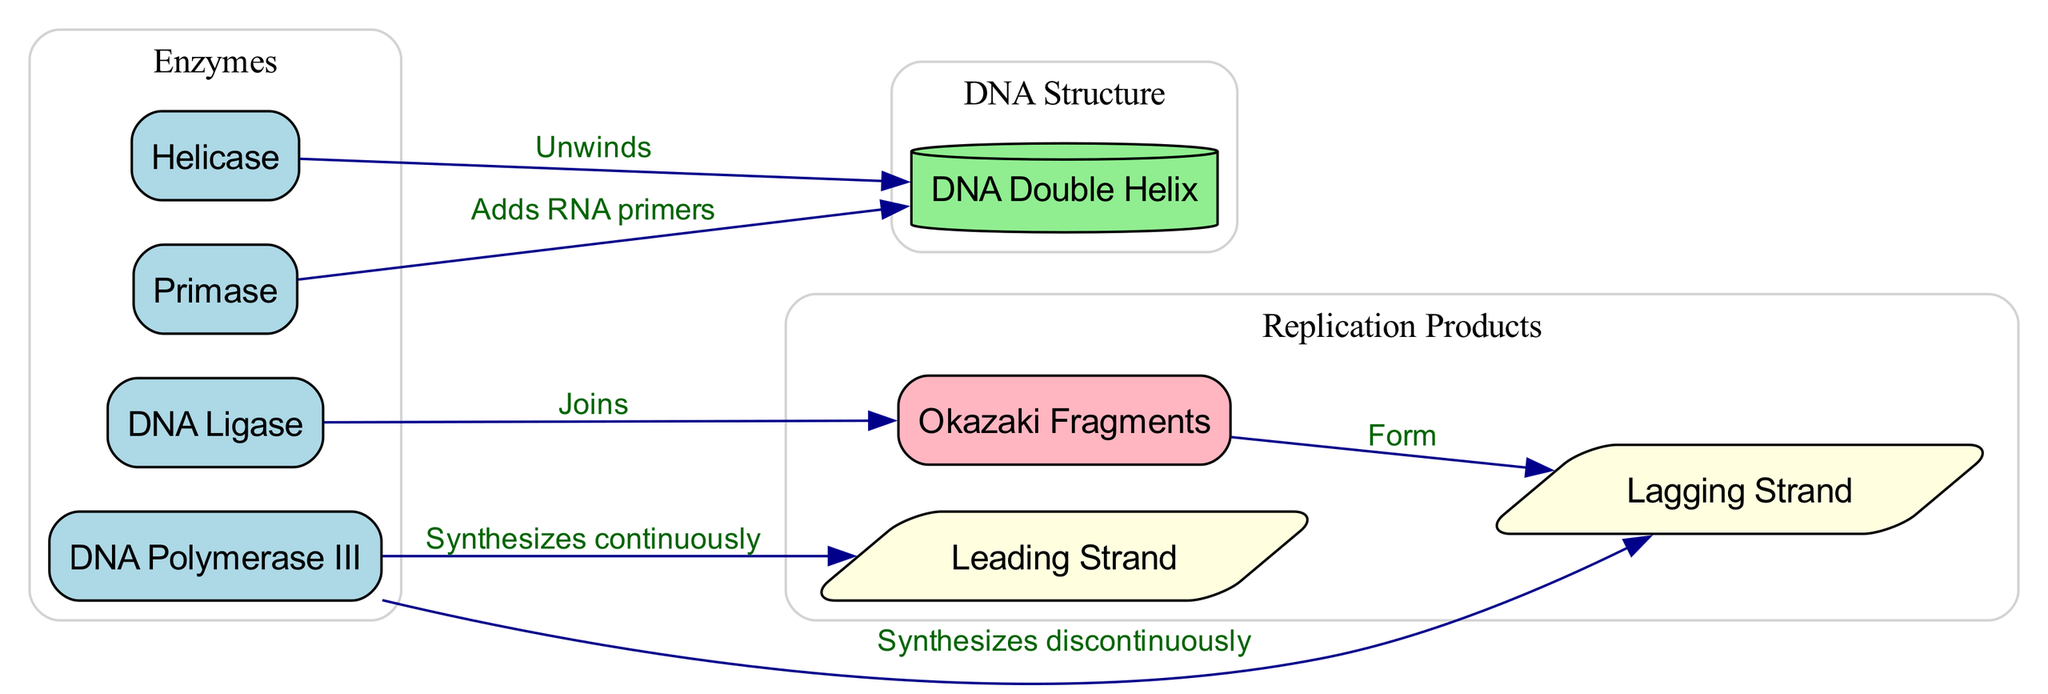What enzyme unwinds the DNA double helix? The diagram shows a directed edge labeled "Unwinds" leading from the node "Helicase" to "DNA Double Helix". This indicates that Helicase is responsible for the unwinding process.
Answer: Helicase What does Primase add to the DNA double helix? The diagram indicates that there is an edge from "Primase" to "DNA Double Helix" labeled "Adds RNA primers". This shows that Primase is responsible for adding RNA primers to the template strand.
Answer: RNA primers How many types of strands are depicted in the diagram? The diagram includes two distinct strands: "Leading Strand" and "Lagging Strand", which are explicitly labeled. This provides a clear count of the strand types present in the diagram.
Answer: 2 Which enzyme synthesizes the leading strand? According to the diagram, there is a directed edge from "DNA Polymerase III" to "Leading Strand" labeled "Synthesizes continuously". This indicates that DNA Polymerase III is the enzyme responsible for synthesizing the leading strand.
Answer: DNA Polymerase III What do Okazaki Fragments do? The diagram demonstrates that there is an edge leading from "Okazaki Fragments" to "Lagging Strand" labeled "Form". This shows that Okazaki Fragments are formed and associated with the lagging strand during DNA replication.
Answer: Form Which enzyme joins Okazaki Fragments? In the diagram, there is a directed edge that connects "Ligase" to "Okazaki Fragments" labeled "Joins". This indicates that DNA Ligase is responsible for joining Okazaki fragments together during DNA replication.
Answer: Ligase Describe the flow of information regarding the synthesis of the lagging strand. The diagram shows that "DNA Polymerase III" synthesizes the lagging strand discontinuously, indicated by the edge labeled "Synthesizes discontinuously". Additionally, it shows that "Okazaki Fragments" are formed and these fragments are later joined by "Ligase", demonstrating how the synthesis process is not continuous but rather in fragments.
Answer: Synthesizes discontinuously, forms Okazaki Fragments, joins by Ligase What is the relationship between Ligase and Okazaki Fragments? The diagram shows a directed edge from "Ligase" to "Okazaki Fragments" labeled "Joins". This indicates that Ligase plays a crucial role in the replication process by connecting the Okazaki Fragments together on the lagging strand, ensuring that the newly synthesized DNA is continuous.
Answer: Joins 